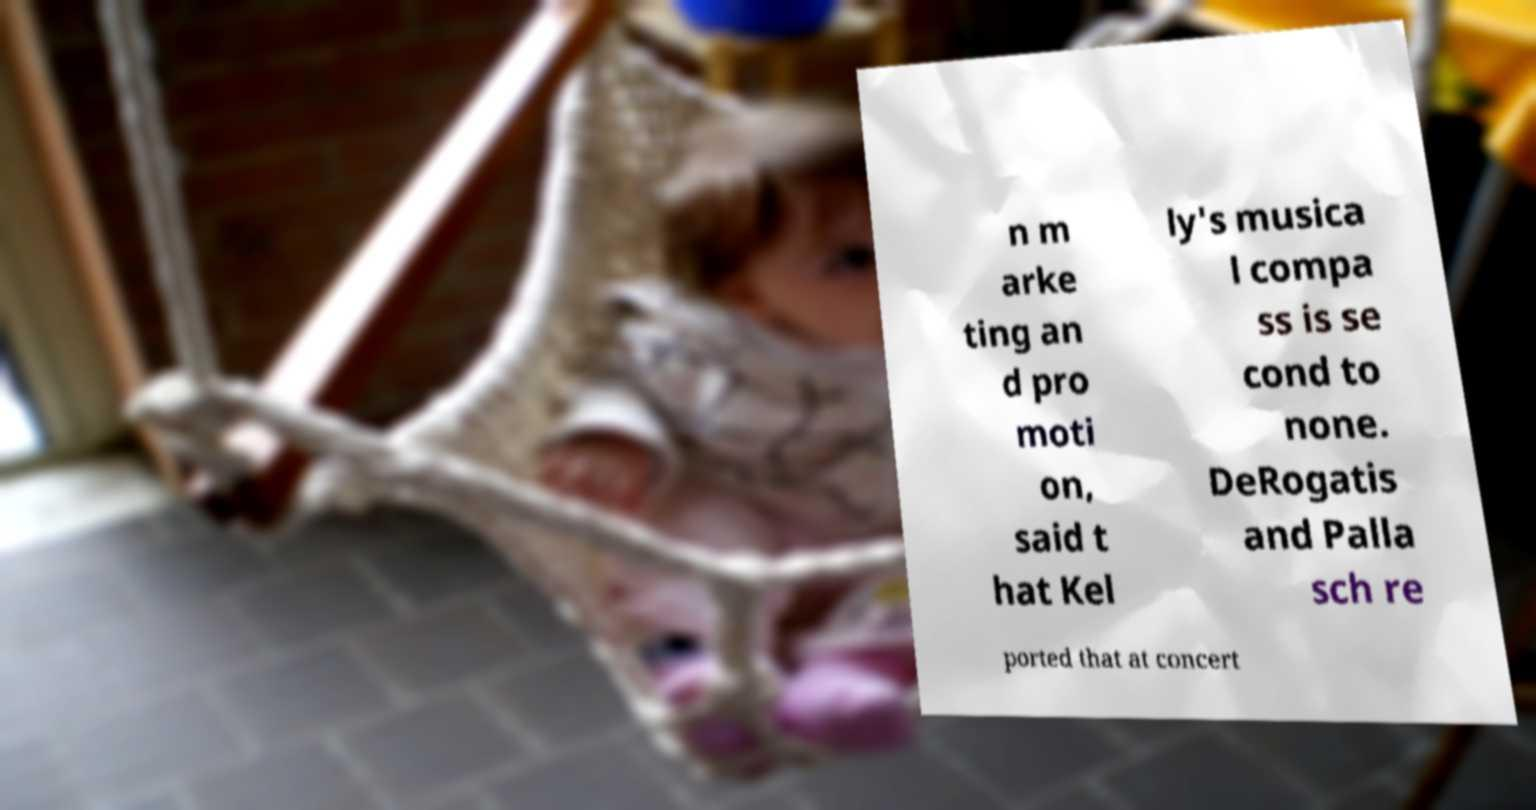For documentation purposes, I need the text within this image transcribed. Could you provide that? n m arke ting an d pro moti on, said t hat Kel ly's musica l compa ss is se cond to none. DeRogatis and Palla sch re ported that at concert 